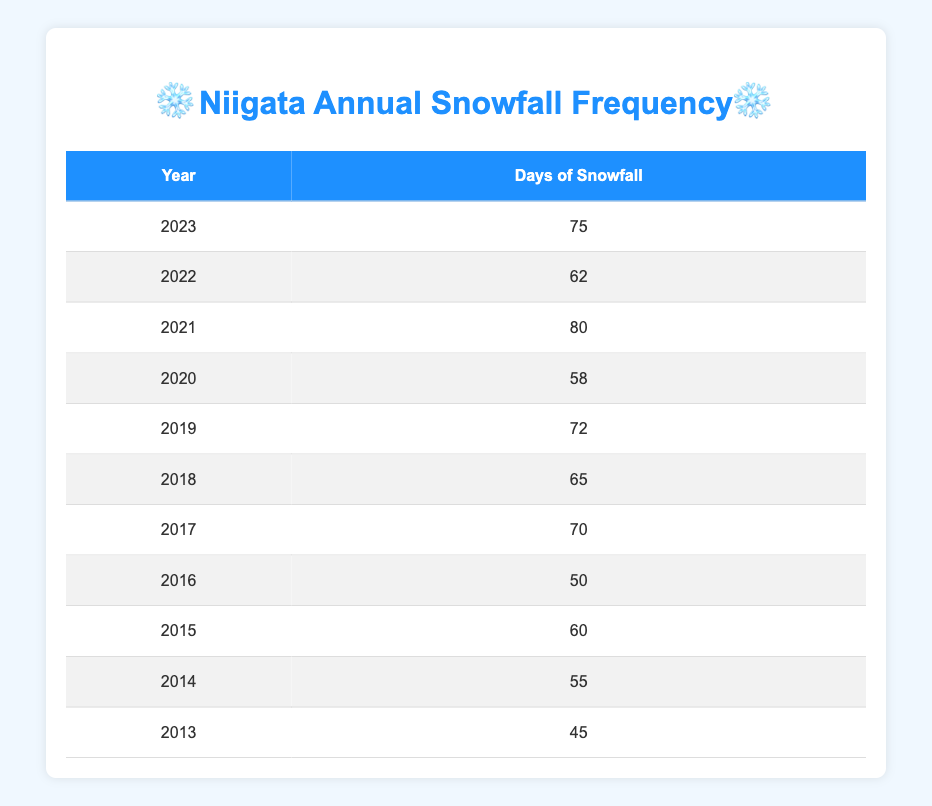What was the highest number of snowfall days in a year? In the table, I can see that the highest number of days of snowfall is recorded in 2021, which has 80 days.
Answer: 80 Which year experienced less than 50 days of snowfall? Looking at the data, there is no year with less than 50 days of snowfall. The lowest recorded is 45 days in 2013, which is still above 50.
Answer: No What is the average number of snowfall days over the last decade? To find the average, I add all the days of snowfall: 45 + 55 + 60 + 50 + 70 + 65 + 72 + 58 + 80 + 62 + 75 =  682. Then I divide this total by the number of years, which is 11. So, 682 / 11 = 62.
Answer: 62 How many years had more than 70 days of snowfall? Scanning the table, the years with more than 70 days of snowfall are 2017 (70 days), 2019 (72 days), and 2021 (80 days). Thus, 3 years had more than 70 days.
Answer: 3 Did Niigata experience more snowfall days in 2023 than in 2016? In 2023, there were 75 days of snowfall, while in 2016 it was only 50 days. Since 75 is greater than 50, the statement is true.
Answer: Yes What is the difference in snowfall days between the year with the most and the least snowfall? The year with the most snowfall is 2021 (80 days), and the least is 2013 (45 days). The difference is 80 - 45 = 35 days.
Answer: 35 Which year had a snowfall frequency of 58 days? By checking the table, I can see that the year 2020 had 58 days of snowfall.
Answer: 2020 What is the total number of snowfall days recorded over the decade? Adding all the snowfall days gives:  45 + 55 + 60 + 50 + 70 + 65 + 72 + 58 + 80 + 62 + 75 = 682 days.
Answer: 682 